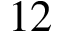<formula> <loc_0><loc_0><loc_500><loc_500>1 2</formula> 